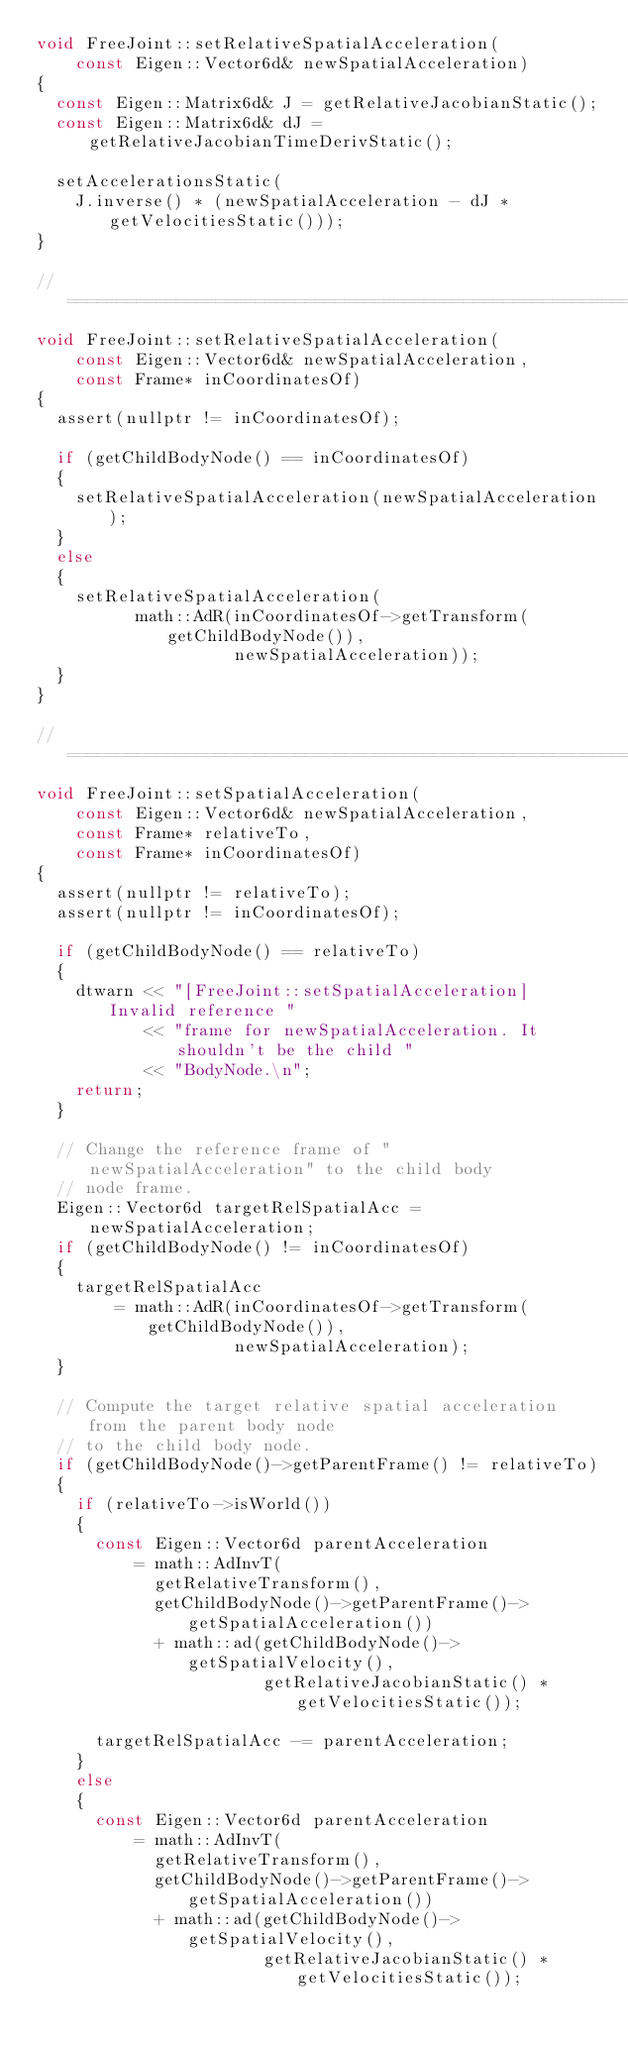<code> <loc_0><loc_0><loc_500><loc_500><_C++_>void FreeJoint::setRelativeSpatialAcceleration(
    const Eigen::Vector6d& newSpatialAcceleration)
{
  const Eigen::Matrix6d& J = getRelativeJacobianStatic();
  const Eigen::Matrix6d& dJ = getRelativeJacobianTimeDerivStatic();

  setAccelerationsStatic(
    J.inverse() * (newSpatialAcceleration - dJ * getVelocitiesStatic()));
}

//==============================================================================
void FreeJoint::setRelativeSpatialAcceleration(
    const Eigen::Vector6d& newSpatialAcceleration,
    const Frame* inCoordinatesOf)
{
  assert(nullptr != inCoordinatesOf);

  if (getChildBodyNode() == inCoordinatesOf)
  {
    setRelativeSpatialAcceleration(newSpatialAcceleration);
  }
  else
  {
    setRelativeSpatialAcceleration(
          math::AdR(inCoordinatesOf->getTransform(getChildBodyNode()),
                    newSpatialAcceleration));
  }
}

//==============================================================================
void FreeJoint::setSpatialAcceleration(
    const Eigen::Vector6d& newSpatialAcceleration,
    const Frame* relativeTo,
    const Frame* inCoordinatesOf)
{
  assert(nullptr != relativeTo);
  assert(nullptr != inCoordinatesOf);

  if (getChildBodyNode() == relativeTo)
  {
    dtwarn << "[FreeJoint::setSpatialAcceleration] Invalid reference "
           << "frame for newSpatialAcceleration. It shouldn't be the child "
           << "BodyNode.\n";
    return;
  }

  // Change the reference frame of "newSpatialAcceleration" to the child body
  // node frame.
  Eigen::Vector6d targetRelSpatialAcc = newSpatialAcceleration;
  if (getChildBodyNode() != inCoordinatesOf)
  {
    targetRelSpatialAcc
        = math::AdR(inCoordinatesOf->getTransform(getChildBodyNode()),
                    newSpatialAcceleration);
  }

  // Compute the target relative spatial acceleration from the parent body node
  // to the child body node.
  if (getChildBodyNode()->getParentFrame() != relativeTo)
  {
    if (relativeTo->isWorld())
    {
      const Eigen::Vector6d parentAcceleration
          = math::AdInvT(
            getRelativeTransform(),
            getChildBodyNode()->getParentFrame()->getSpatialAcceleration())
            + math::ad(getChildBodyNode()->getSpatialVelocity(),
                       getRelativeJacobianStatic() * getVelocitiesStatic());

      targetRelSpatialAcc -= parentAcceleration;
    }
    else
    {
      const Eigen::Vector6d parentAcceleration
          = math::AdInvT(
            getRelativeTransform(),
            getChildBodyNode()->getParentFrame()->getSpatialAcceleration())
            + math::ad(getChildBodyNode()->getSpatialVelocity(),
                       getRelativeJacobianStatic() * getVelocitiesStatic());</code> 